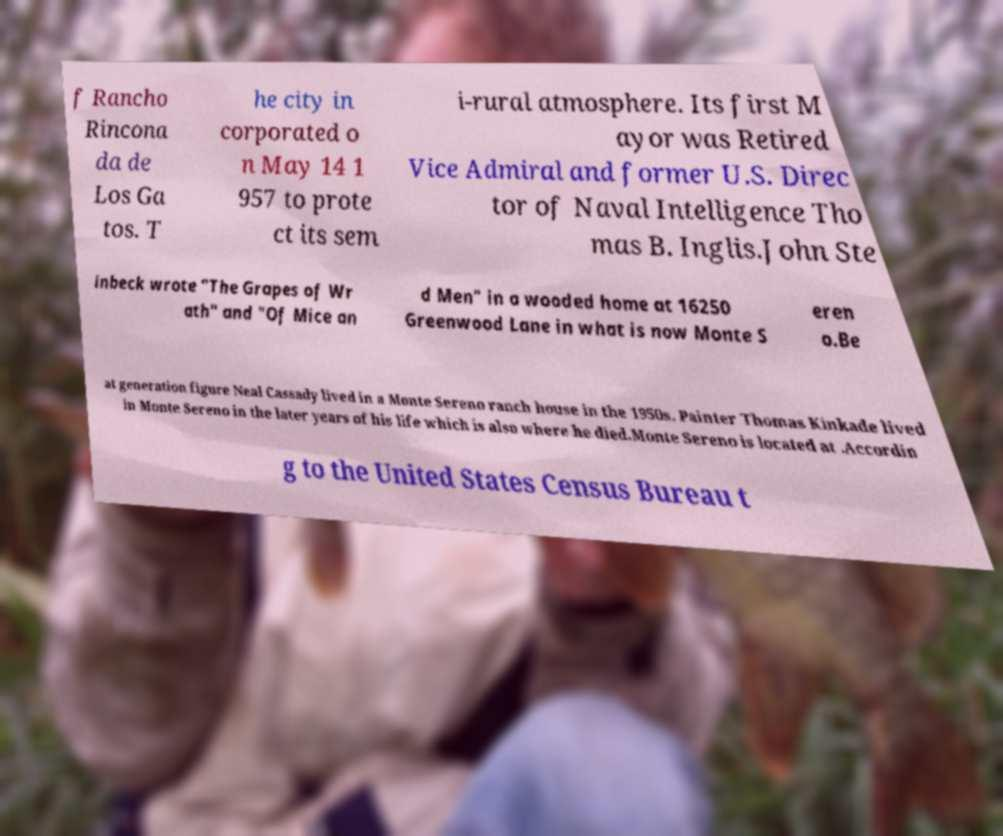Can you read and provide the text displayed in the image?This photo seems to have some interesting text. Can you extract and type it out for me? f Rancho Rincona da de Los Ga tos. T he city in corporated o n May 14 1 957 to prote ct its sem i-rural atmosphere. Its first M ayor was Retired Vice Admiral and former U.S. Direc tor of Naval Intelligence Tho mas B. Inglis.John Ste inbeck wrote "The Grapes of Wr ath" and "Of Mice an d Men" in a wooded home at 16250 Greenwood Lane in what is now Monte S eren o.Be at generation figure Neal Cassady lived in a Monte Sereno ranch house in the 1950s. Painter Thomas Kinkade lived in Monte Sereno in the later years of his life which is also where he died.Monte Sereno is located at .Accordin g to the United States Census Bureau t 